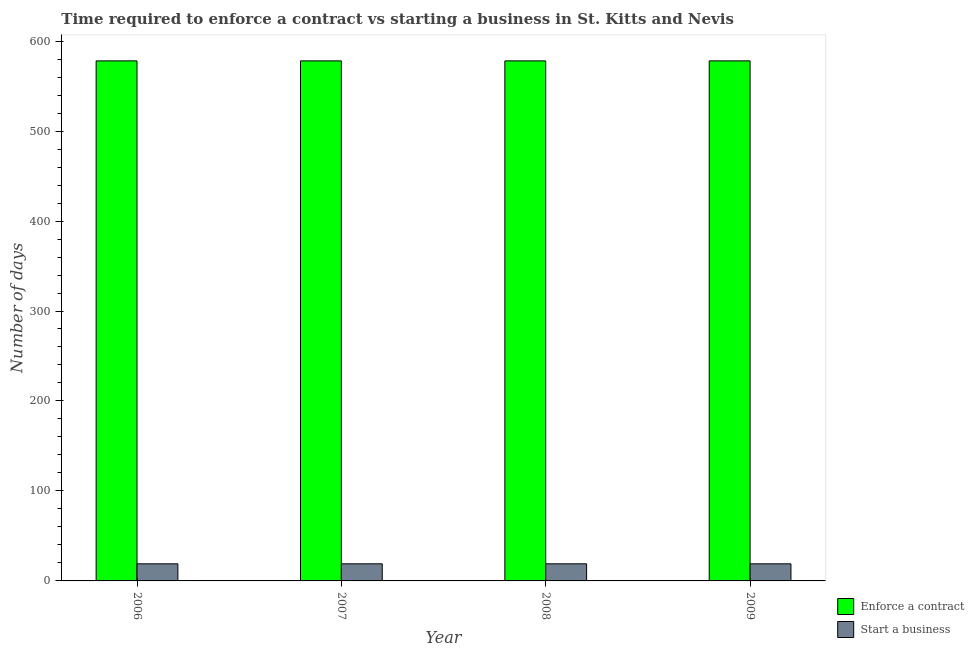How many groups of bars are there?
Offer a terse response. 4. Are the number of bars on each tick of the X-axis equal?
Ensure brevity in your answer.  Yes. How many bars are there on the 3rd tick from the left?
Your response must be concise. 2. In how many cases, is the number of bars for a given year not equal to the number of legend labels?
Provide a succinct answer. 0. What is the number of days to enforece a contract in 2006?
Provide a short and direct response. 578. Across all years, what is the maximum number of days to enforece a contract?
Ensure brevity in your answer.  578. Across all years, what is the minimum number of days to enforece a contract?
Offer a very short reply. 578. What is the difference between the number of days to enforece a contract in 2007 and that in 2008?
Ensure brevity in your answer.  0. What is the difference between the number of days to enforece a contract in 2009 and the number of days to start a business in 2008?
Make the answer very short. 0. What is the average number of days to enforece a contract per year?
Offer a very short reply. 578. In the year 2009, what is the difference between the number of days to enforece a contract and number of days to start a business?
Offer a very short reply. 0. Is the number of days to enforece a contract in 2008 less than that in 2009?
Offer a terse response. No. Is the difference between the number of days to enforece a contract in 2006 and 2008 greater than the difference between the number of days to start a business in 2006 and 2008?
Your answer should be compact. No. What is the difference between the highest and the second highest number of days to enforece a contract?
Provide a succinct answer. 0. Is the sum of the number of days to start a business in 2007 and 2009 greater than the maximum number of days to enforece a contract across all years?
Offer a terse response. Yes. What does the 1st bar from the left in 2006 represents?
Give a very brief answer. Enforce a contract. What does the 1st bar from the right in 2007 represents?
Keep it short and to the point. Start a business. How many years are there in the graph?
Keep it short and to the point. 4. Does the graph contain grids?
Your answer should be very brief. No. Where does the legend appear in the graph?
Your answer should be very brief. Bottom right. What is the title of the graph?
Offer a very short reply. Time required to enforce a contract vs starting a business in St. Kitts and Nevis. Does "Girls" appear as one of the legend labels in the graph?
Give a very brief answer. No. What is the label or title of the X-axis?
Offer a terse response. Year. What is the label or title of the Y-axis?
Keep it short and to the point. Number of days. What is the Number of days of Enforce a contract in 2006?
Give a very brief answer. 578. What is the Number of days in Start a business in 2006?
Your answer should be very brief. 19. What is the Number of days of Enforce a contract in 2007?
Make the answer very short. 578. What is the Number of days in Enforce a contract in 2008?
Give a very brief answer. 578. What is the Number of days in Start a business in 2008?
Your response must be concise. 19. What is the Number of days of Enforce a contract in 2009?
Provide a succinct answer. 578. What is the Number of days in Start a business in 2009?
Keep it short and to the point. 19. Across all years, what is the maximum Number of days in Enforce a contract?
Your answer should be compact. 578. Across all years, what is the minimum Number of days in Enforce a contract?
Offer a terse response. 578. What is the total Number of days in Enforce a contract in the graph?
Your response must be concise. 2312. What is the total Number of days of Start a business in the graph?
Offer a very short reply. 76. What is the difference between the Number of days in Start a business in 2006 and that in 2008?
Your response must be concise. 0. What is the difference between the Number of days in Enforce a contract in 2007 and that in 2009?
Offer a very short reply. 0. What is the difference between the Number of days in Enforce a contract in 2006 and the Number of days in Start a business in 2007?
Ensure brevity in your answer.  559. What is the difference between the Number of days in Enforce a contract in 2006 and the Number of days in Start a business in 2008?
Your answer should be compact. 559. What is the difference between the Number of days in Enforce a contract in 2006 and the Number of days in Start a business in 2009?
Offer a terse response. 559. What is the difference between the Number of days in Enforce a contract in 2007 and the Number of days in Start a business in 2008?
Offer a very short reply. 559. What is the difference between the Number of days in Enforce a contract in 2007 and the Number of days in Start a business in 2009?
Offer a terse response. 559. What is the difference between the Number of days of Enforce a contract in 2008 and the Number of days of Start a business in 2009?
Offer a terse response. 559. What is the average Number of days in Enforce a contract per year?
Your answer should be compact. 578. What is the average Number of days of Start a business per year?
Keep it short and to the point. 19. In the year 2006, what is the difference between the Number of days in Enforce a contract and Number of days in Start a business?
Keep it short and to the point. 559. In the year 2007, what is the difference between the Number of days in Enforce a contract and Number of days in Start a business?
Your answer should be very brief. 559. In the year 2008, what is the difference between the Number of days in Enforce a contract and Number of days in Start a business?
Offer a very short reply. 559. In the year 2009, what is the difference between the Number of days of Enforce a contract and Number of days of Start a business?
Keep it short and to the point. 559. What is the ratio of the Number of days of Enforce a contract in 2006 to that in 2007?
Offer a terse response. 1. What is the ratio of the Number of days in Start a business in 2006 to that in 2007?
Provide a succinct answer. 1. What is the ratio of the Number of days of Enforce a contract in 2006 to that in 2009?
Keep it short and to the point. 1. What is the ratio of the Number of days of Start a business in 2006 to that in 2009?
Make the answer very short. 1. What is the ratio of the Number of days in Enforce a contract in 2007 to that in 2009?
Offer a terse response. 1. What is the ratio of the Number of days of Enforce a contract in 2008 to that in 2009?
Keep it short and to the point. 1. What is the ratio of the Number of days of Start a business in 2008 to that in 2009?
Offer a terse response. 1. What is the difference between the highest and the second highest Number of days of Start a business?
Offer a terse response. 0. What is the difference between the highest and the lowest Number of days in Enforce a contract?
Offer a terse response. 0. What is the difference between the highest and the lowest Number of days in Start a business?
Keep it short and to the point. 0. 